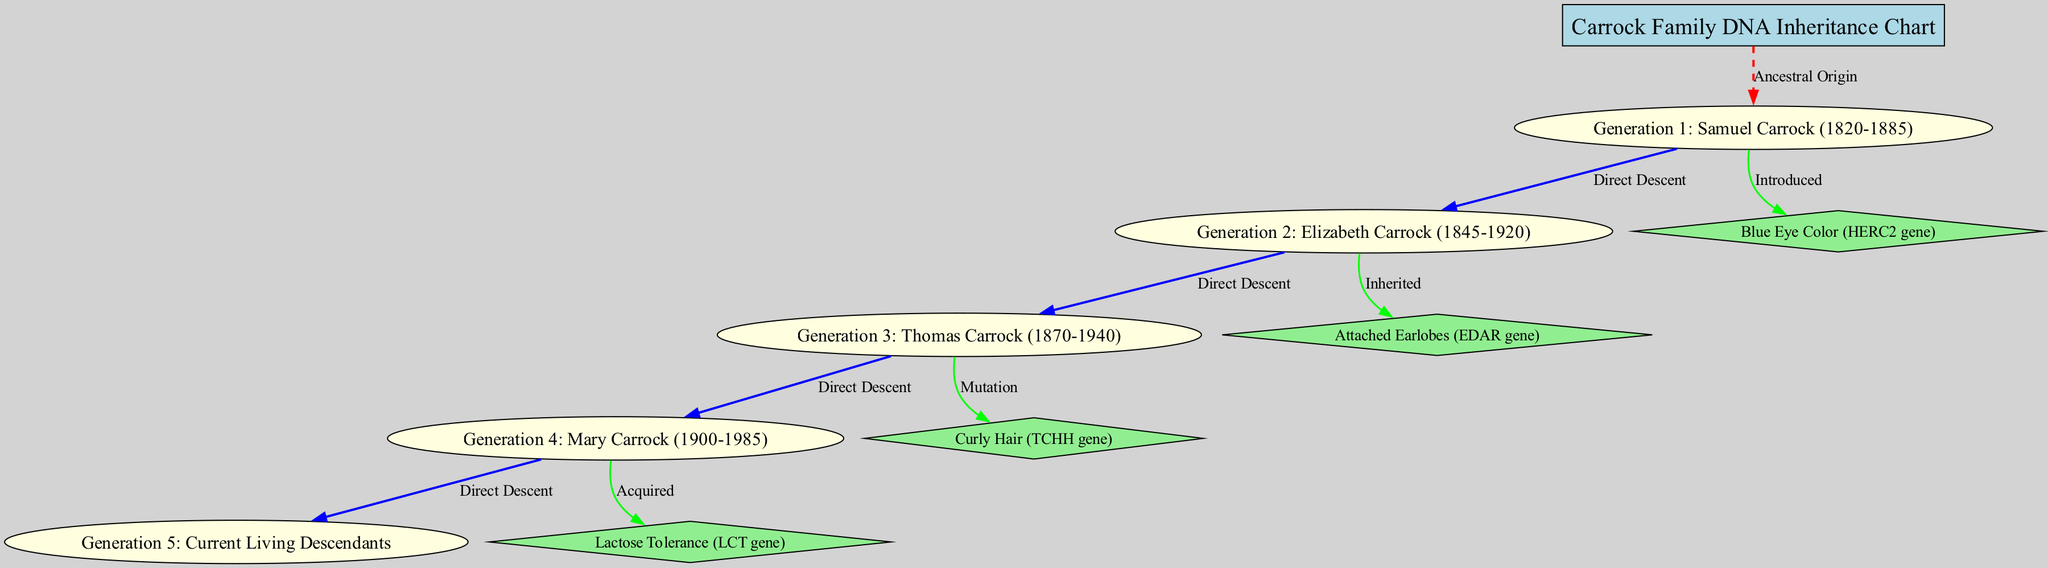What's the title of the diagram? The title is shown at the top as the main node labeled "Carrock Family DNA Inheritance Chart".
Answer: Carrock Family DNA Inheritance Chart How many generations are represented in the chart? The chart includes five nodes that correspond to four generations plus the current living descendants, making it a total of five generations.
Answer: 5 Which trait was introduced by Samuel Carrock? By tracing the edge labeled "Introduced" that connects Samuel Carrock to a specific trait, we find that the trait listed is "Blue Eye Color" associated with the HERC2 gene.
Answer: Blue Eye Color What is the relationship between Mary Carrock and the current living descendants? Following the edges marked "Direct Descent", we can see that Mary Carrock is one generation above the current living descendants, signifying she is their ancestor.
Answer: Ancestor Which trait is inherited through Generation 2? The edge connecting Generation 2 to a trait is labeled "Inherited", and the trait associated with it is "Attached Earlobes", which corresponds to the EDAR gene.
Answer: Attached Earlobes How many traits are displayed in the diagram? Counting the trait nodes, there are four traits listed: Blue Eye Color, Attached Earlobes, Curly Hair, and Lactose Tolerance.
Answer: 4 Which trait came from a mutation and in which generation does it occur? The edge from Generation 3 to its corresponding trait shows it is denoted as a "Mutation"; the trait is "Curly Hair", associated with the TCHH gene.
Answer: Curly Hair What color is used to represent direct descent relationships in the diagram? The edges labeled as "Direct Descent" are depicted in blue color, as indicated by the coloring specified for these connections.
Answer: Blue What unique trait was acquired in Generation 4? Referring to the edge labeled "Acquired", we can see that the trait linked to Generation 4 is "Lactose Tolerance", corresponding to the LCT gene.
Answer: Lactose Tolerance 